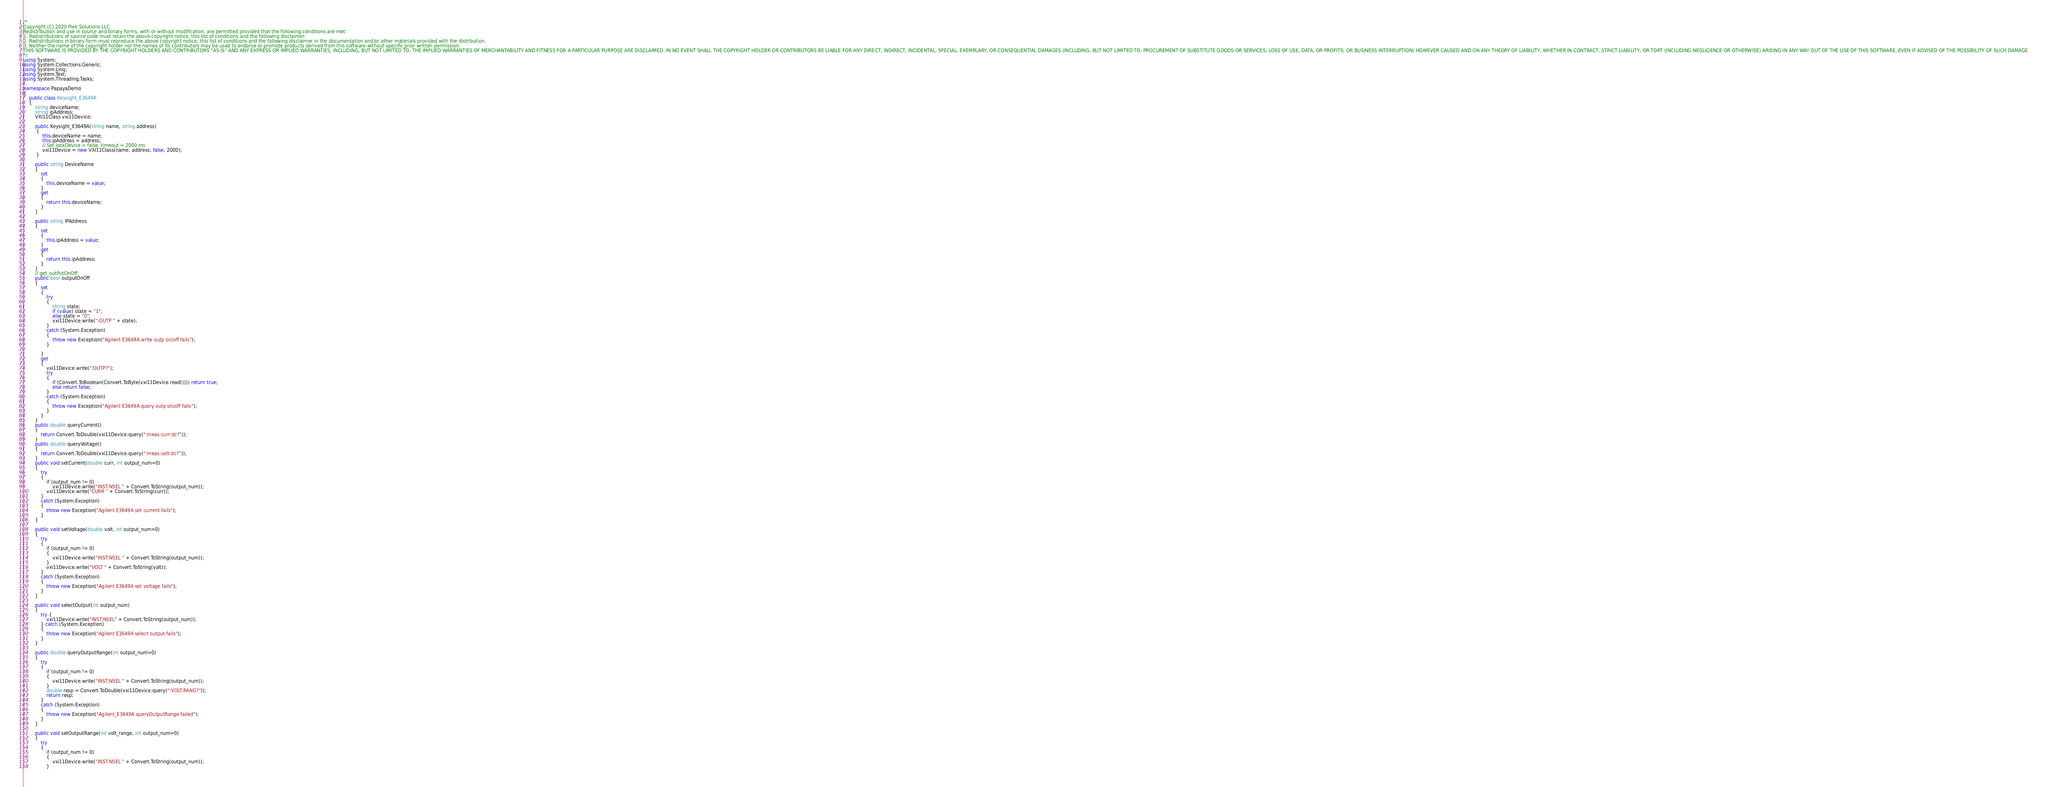Convert code to text. <code><loc_0><loc_0><loc_500><loc_500><_C#_>/*
Copyright (C) 2020 Piek Solutions LLC
Redistribution and use in source and binary forms, with or without modification, are permitted provided that the following conditions are met:
1. Redistributions of source code must retain the above copyright notice, this list of conditions and the following disclaimer.
2. Redistributions in binary form must reproduce the above copyright notice, this list of conditions and the following disclaimer in the documentation and/or other materials provided with the distribution.
3. Neither the name of the copyright holder nor the names of its contributors may be used to endorse or promote products derived from this software without specific prior written permission.
THIS SOFTWARE IS PROVIDED BY THE COPYRIGHT HOLDERS AND CONTRIBUTORS "AS IS" AND ANY EXPRESS OR IMPLIED WARRANTIES, INCLUDING, BUT NOT LIMITED TO, THE IMPLIED WARRANTIES OF MERCHANTABILITY AND FITNESS FOR A PARTICULAR PURPOSE ARE DISCLAIMED. IN NO EVENT SHALL THE COPYRIGHT HOLDER OR CONTRIBUTORS BE LIABLE FOR ANY DIRECT, INDIRECT, INCIDENTAL, SPECIAL, EXEMPLARY, OR CONSEQUENTIAL DAMAGES (INCLUDING, BUT NOT LIMITED TO, PROCUREMENT OF SUBSTITUTE GOODS OR SERVICES; LOSS OF USE, DATA, OR PROFITS; OR BUSINESS INTERRUPTION) HOWEVER CAUSED AND ON ANY THEORY OF LIABILITY, WHETHER IN CONTRACT, STRICT LIABILITY, OR TORT (INCLUDING NEGLIGENCE OR OTHERWISE) ARISING IN ANY WAY OUT OF THE USE OF THIS SOFTWARE, EVEN IF ADVISED OF THE POSSIBILITY OF SUCH DAMAGE.
*/
using System;
using System.Collections.Generic;
using System.Linq;
using System.Text;
using System.Threading.Tasks;

namespace PapayaDemo
{
    public class Keysight_E3649A
    {
        string deviceName;
        string ipAddress;
        VXI11Class vxi11Device;

        public Keysight_E3649A(string name, string address)
         {
             this.deviceName = name;
             this.ipAddress = address;
             // Set lockDevice = false, timeout = 2000 ms
             vxi11Device = new VXI11Class(name, address, false, 2000);
         }

        public string DeviceName
        {
            set
            {
                this.deviceName = value;
            }
            get
            {
                return this.deviceName;
            }
        }

        public string IPAddress
        {
            set
            {
                this.ipAddress = value;
            }
            get
            {
                return this.ipAddress;
            }
        }
        // get_outPutOnOff
        public bool outputOnOff
        {
            set 
            {
                try
                {
                    string state;
                    if (value) state = "1";
                    else state = "0";
                    vxi11Device.write(":OUTP " + state);
                }
                catch (System.Exception)
                {
                    throw new Exception("Agilent E3649A write outp on/off fails");
                }
                
            }
            get 
            {
                vxi11Device.write(":OUTP?");
                try 
                {
                    if (Convert.ToBoolean(Convert.ToByte(vxi11Device.read()))) return true;
                    else return false;
                }
                catch (System.Exception)
                {
                    throw new Exception("Agilent E3649A query outp on/off fails");
                }
            }
        }
        public double queryCurrent()
        {
            return Convert.ToDouble(vxi11Device.query(":meas:curr:dc?"));
        }
        public double queryVoltage()
        {
            return Convert.ToDouble(vxi11Device.query(":meas:volt:dc?"));
        }
        public void setCurrent(double curr, int output_num=0) 
        {
            try
            {
                if (output_num != 0) 
                    vxi11Device.write("INST:NSEL " + Convert.ToString(output_num));
                vxi11Device.write("CURR " + Convert.ToString(curr));
            }
            catch (System.Exception)
            {
                throw new Exception("Agilent E3649A set current fails");
            }
        }

        public void setVoltage(double volt, int output_num=0) 
        {
            try
            {
                if (output_num != 0) 
                {
                    vxi11Device.write("INST:NSEL " + Convert.ToString(output_num));
                } 
                vxi11Device.write("VOLT " + Convert.ToString(volt));
            }
            catch (System.Exception)
            {
                throw new Exception("Agilent E3649A set voltage fails");
            }
        }

        public void selectOutput(int output_num)
        {
            try {
                vxi11Device.write("INST:NSEL" + Convert.ToString(output_num));
            } catch (System.Exception)
            {
                throw new Exception("Agilent E3649A select output fails");
            }
        }

        public double queryOutputRange(int output_num=0)
        {
            try
            {
                if (output_num != 0) 
                {
                    vxi11Device.write("INST:NSEL " + Convert.ToString(output_num));
                }
                double resp = Convert.ToDouble(vxi11Device.query(":VOLT:RANG?"));
                return resp;
            }
            catch (System.Exception)
            {
                throw new Exception("Agilent_E3649A queryOutputRange failed");
            }
        }

        public void setOutputRange(int volt_range, int output_num=0)
        {
            try
            {
                if (output_num != 0) 
                {
                    vxi11Device.write("INST:NSEL " + Convert.ToString(output_num));
                }</code> 